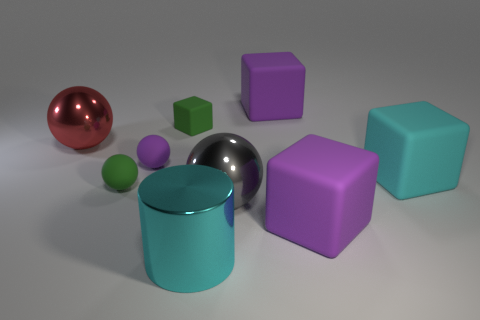Subtract all red balls. How many purple blocks are left? 2 Subtract all green matte cubes. How many cubes are left? 3 Add 1 gray matte balls. How many objects exist? 10 Subtract all purple balls. How many balls are left? 3 Subtract all cylinders. How many objects are left? 8 Subtract all cyan matte objects. Subtract all red spheres. How many objects are left? 7 Add 6 large shiny balls. How many large shiny balls are left? 8 Add 8 big gray things. How many big gray things exist? 9 Subtract 1 purple balls. How many objects are left? 8 Subtract all purple spheres. Subtract all gray cylinders. How many spheres are left? 3 